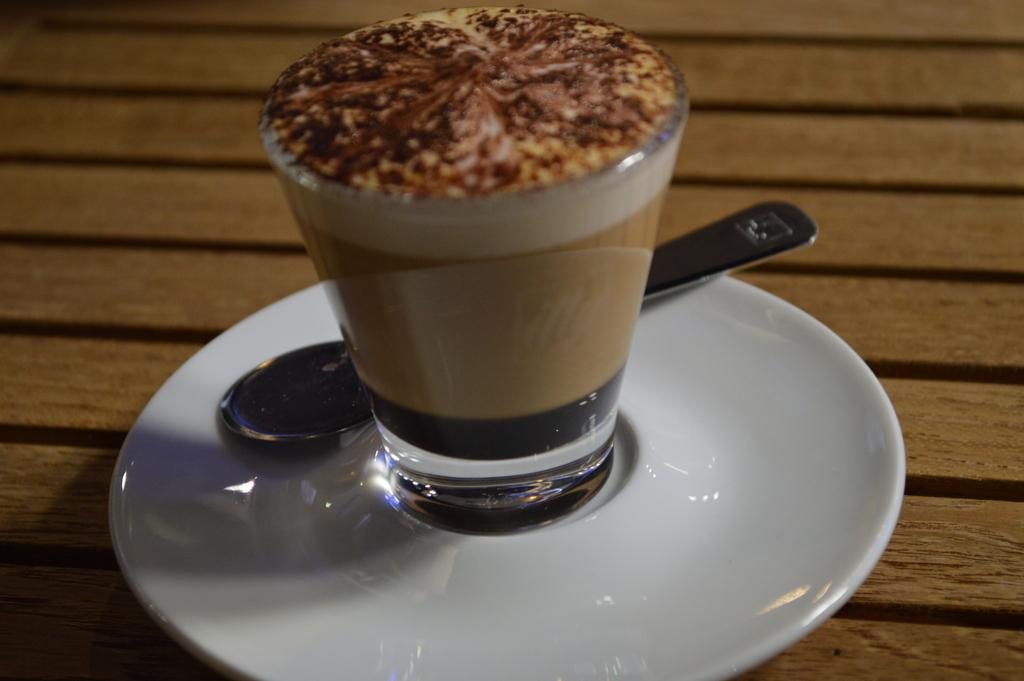What piece of furniture is visible in the image? There is a table in the image. What is placed on the table? A plate and a glass of drink are present on the table. What utensil is in the plate? A spoon is in the plate. How many cats are sitting on the table in the image? There are no cats present in the image. 